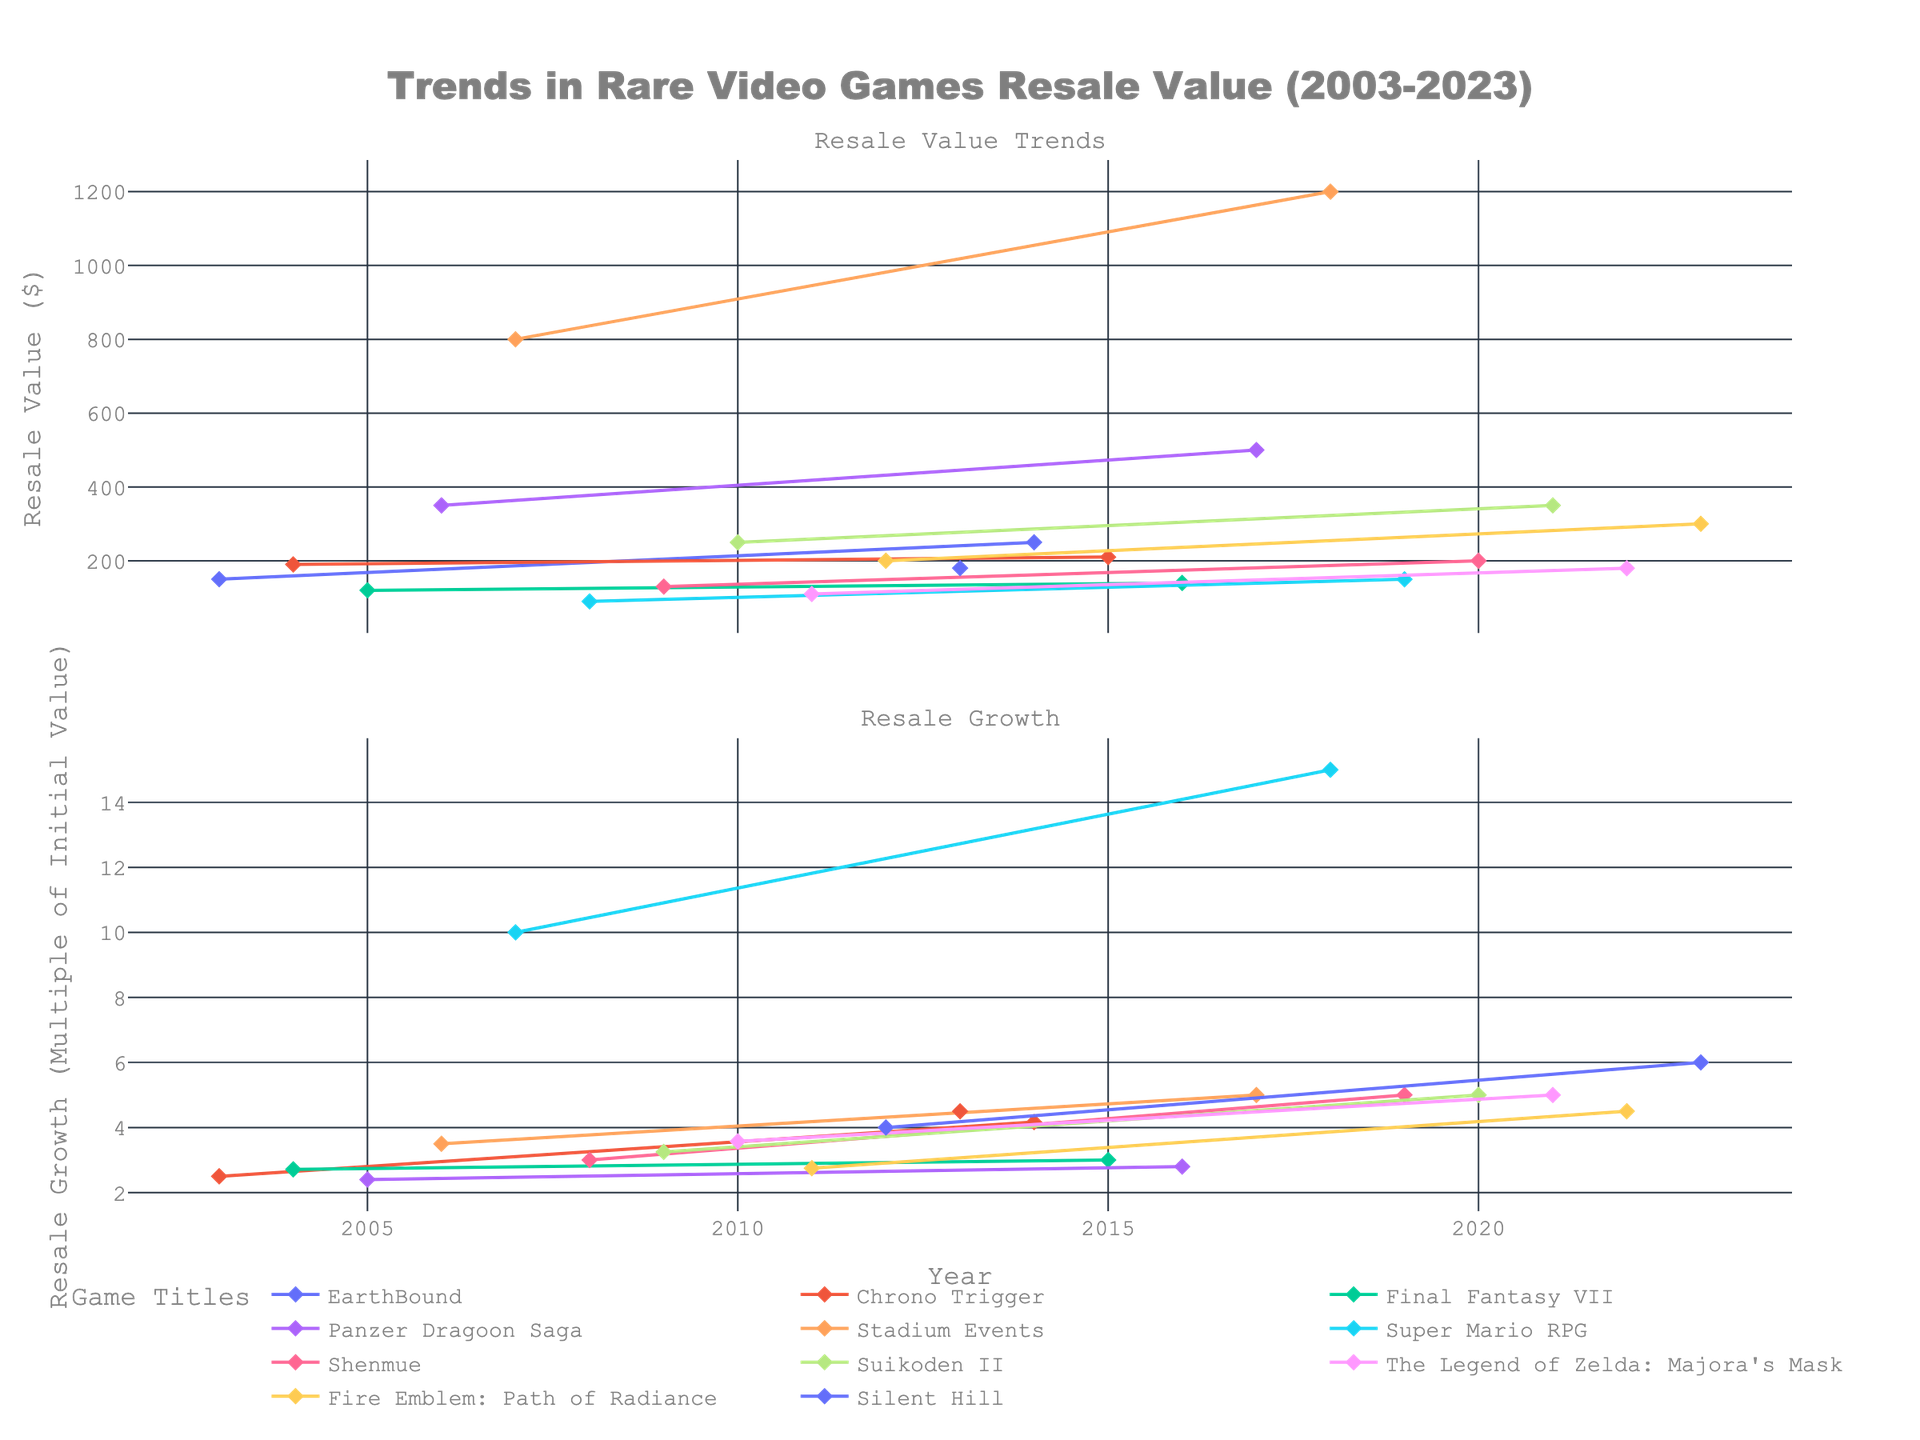What's the title of the figure? The title is prominently displayed at the top center of the figure. It summarizes the content of the plots.
Answer: Trends in Rare Video Games Resale Value (2003-2023) How many subplots are there in the figure? By observing the vertical sections separated by titles, there are two main subplots in the figure.
Answer: 2 Which game shows the highest resale value in 2023? Focus on the resale value subplot for the year 2023. Identify the highest point and trace it to the associated game.
Answer: Fire Emblem: Path of Radiance What is the overall trend in the resale value of "Panzer Dragoon Saga"? Follow the line representing "Panzer Dragoon Saga" in the resale value subplot from 2006 to 2017. Notice the steep incline in resale value over time.
Answer: Increasing Which game title has the highest resale growth in the final year plotted? In the resale growth subplot, find the year 2023 on the x-axis and identify which game reaches the highest multiple of initial value.
Answer: Fire Emblem: Path of Radiance Compare the resale values of "Stadium Events" in 2007 and 2018. Which year had a higher resale value and by how much? Locate the points for "Stadium Events" in 2007 and 2018 in the resale value subplot. Calculate the difference between the values (1200 - 800 = 400).
Answer: 2018, by $400 What pattern do you observe in the resale growth of "EarthBound" over the years? Examine the resale growth subplot for the points corresponding to "EarthBound" from 2003 to 2014. Identify any major changes and trends.
Answer: Increasing growth pattern During which year did "Suikoden II" experience the most significant increase in resale value? Inspect the resale value subplot for "Suikoden II" and find the year with the steepest rise between adjacent points (2020 to 2021).
Answer: 2021 How does the resale value trend of "Final Fantasy VII" compare from its initial year to the last year recorded? Look at the points for "Final Fantasy VII" in the resale value subplot from 2005 to 2016, noting the starting and ending resale values. Identify the trend direction.
Answer: Slightly increasing 